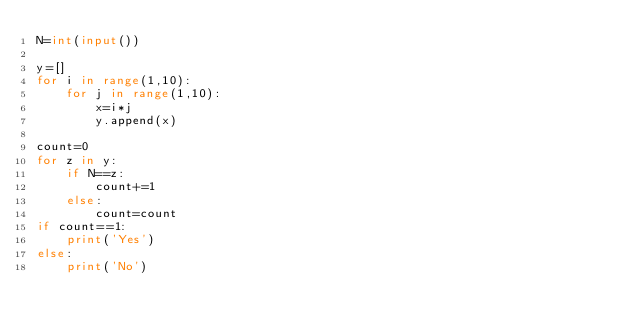<code> <loc_0><loc_0><loc_500><loc_500><_Python_>N=int(input())

y=[]
for i in range(1,10):
    for j in range(1,10):
        x=i*j
        y.append(x)

count=0
for z in y:
    if N==z:
        count+=1
    else:
        count=count
if count==1:
    print('Yes')
else:
    print('No')</code> 